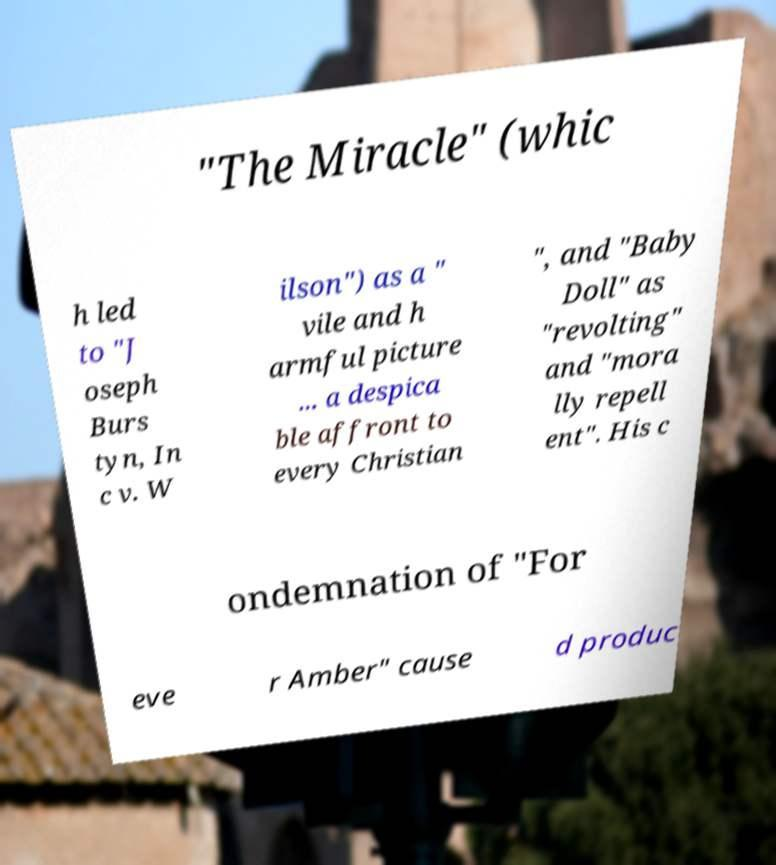Please read and relay the text visible in this image. What does it say? "The Miracle" (whic h led to "J oseph Burs tyn, In c v. W ilson") as a " vile and h armful picture ... a despica ble affront to every Christian ", and "Baby Doll" as "revolting" and "mora lly repell ent". His c ondemnation of "For eve r Amber" cause d produc 